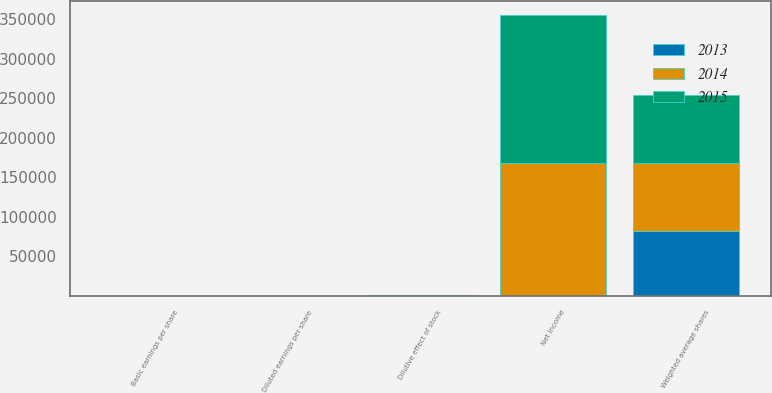<chart> <loc_0><loc_0><loc_500><loc_500><stacked_bar_chart><ecel><fcel>Net Income<fcel>Weighted average shares<fcel>Dilutive effect of stock<fcel>Basic earnings per share<fcel>Diluted earnings per share<nl><fcel>2013<fcel>579<fcel>81601<fcel>248<fcel>2.6<fcel>2.59<nl><fcel>2015<fcel>186715<fcel>85396<fcel>530<fcel>2.2<fcel>2.19<nl><fcel>2014<fcel>167610<fcel>86619<fcel>579<fcel>1.95<fcel>1.94<nl></chart> 